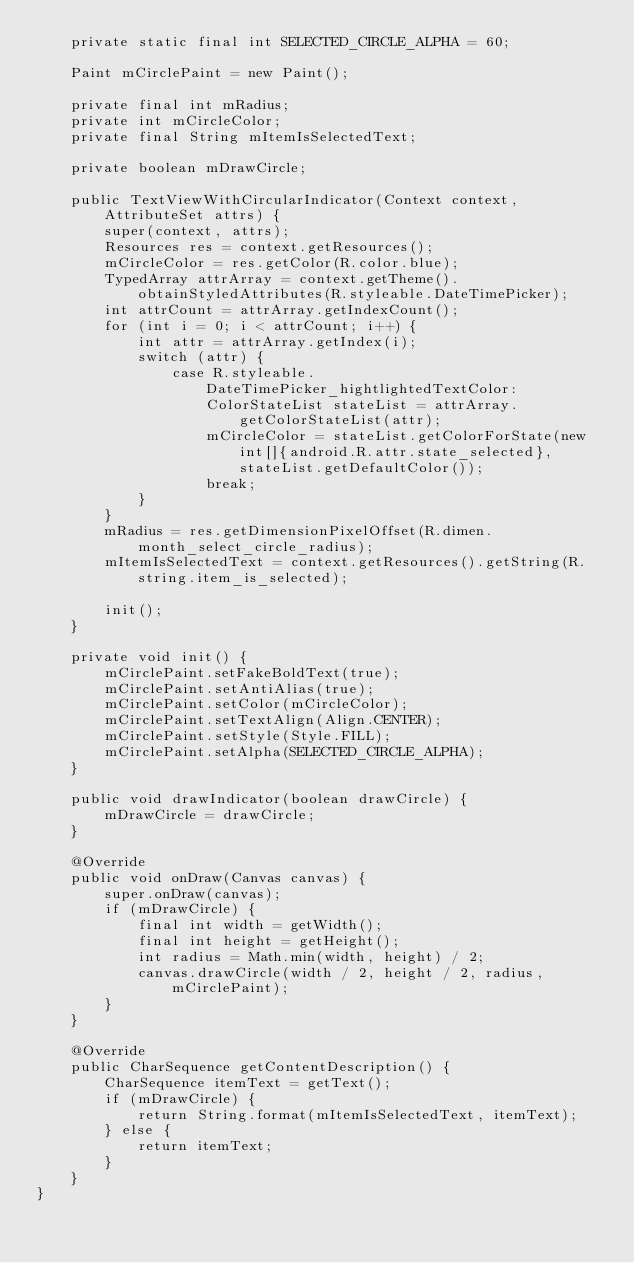Convert code to text. <code><loc_0><loc_0><loc_500><loc_500><_Java_>    private static final int SELECTED_CIRCLE_ALPHA = 60;

    Paint mCirclePaint = new Paint();

    private final int mRadius;
    private int mCircleColor;
    private final String mItemIsSelectedText;

    private boolean mDrawCircle;

    public TextViewWithCircularIndicator(Context context, AttributeSet attrs) {
        super(context, attrs);
        Resources res = context.getResources();
        mCircleColor = res.getColor(R.color.blue);
        TypedArray attrArray = context.getTheme().obtainStyledAttributes(R.styleable.DateTimePicker);
        int attrCount = attrArray.getIndexCount();
        for (int i = 0; i < attrCount; i++) {
            int attr = attrArray.getIndex(i);
            switch (attr) {
                case R.styleable.DateTimePicker_hightlightedTextColor:
                    ColorStateList stateList = attrArray.getColorStateList(attr);
                    mCircleColor = stateList.getColorForState(new int[]{android.R.attr.state_selected}, stateList.getDefaultColor());
                    break;
            }
        }
        mRadius = res.getDimensionPixelOffset(R.dimen.month_select_circle_radius);
        mItemIsSelectedText = context.getResources().getString(R.string.item_is_selected);

        init();
    }

    private void init() {
        mCirclePaint.setFakeBoldText(true);
        mCirclePaint.setAntiAlias(true);
        mCirclePaint.setColor(mCircleColor);
        mCirclePaint.setTextAlign(Align.CENTER);
        mCirclePaint.setStyle(Style.FILL);
        mCirclePaint.setAlpha(SELECTED_CIRCLE_ALPHA);
    }

    public void drawIndicator(boolean drawCircle) {
        mDrawCircle = drawCircle;
    }

    @Override
    public void onDraw(Canvas canvas) {
        super.onDraw(canvas);
        if (mDrawCircle) {
            final int width = getWidth();
            final int height = getHeight();
            int radius = Math.min(width, height) / 2;
            canvas.drawCircle(width / 2, height / 2, radius, mCirclePaint);
        }
    }

    @Override
    public CharSequence getContentDescription() {
        CharSequence itemText = getText();
        if (mDrawCircle) {
            return String.format(mItemIsSelectedText, itemText);
        } else {
            return itemText;
        }
    }
}
</code> 